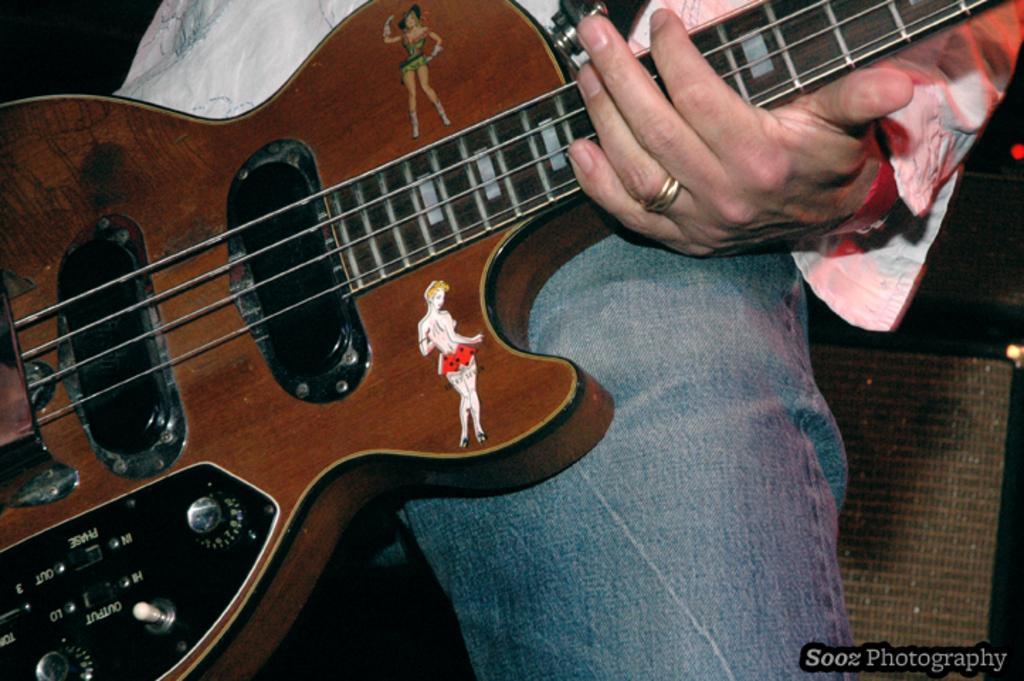Can you describe this image briefly? In this picture we can see a person wearing a white colour shirt and a denim jeans in blue colour, holding guitar in his hands. On the guitar we can see stickers of a woman. 